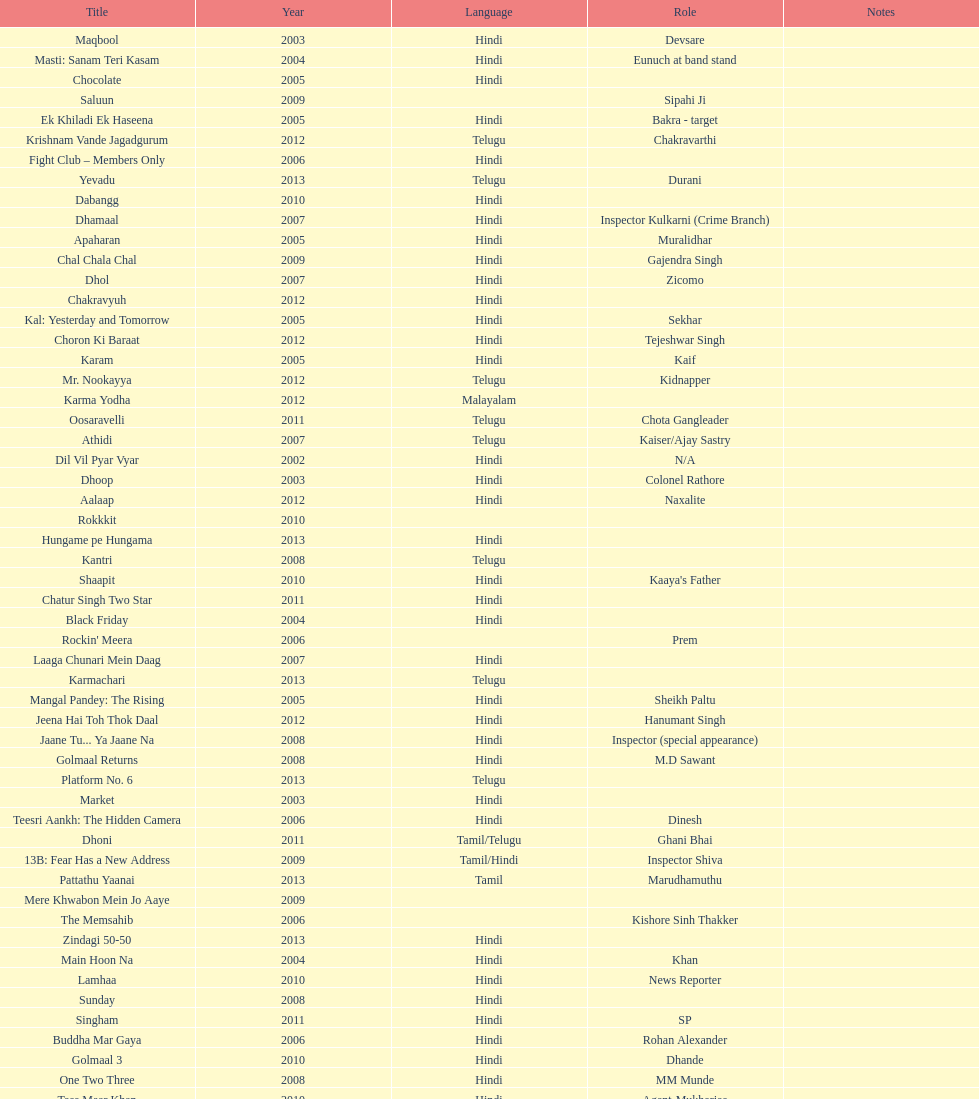What is the total years on the chart 13. 